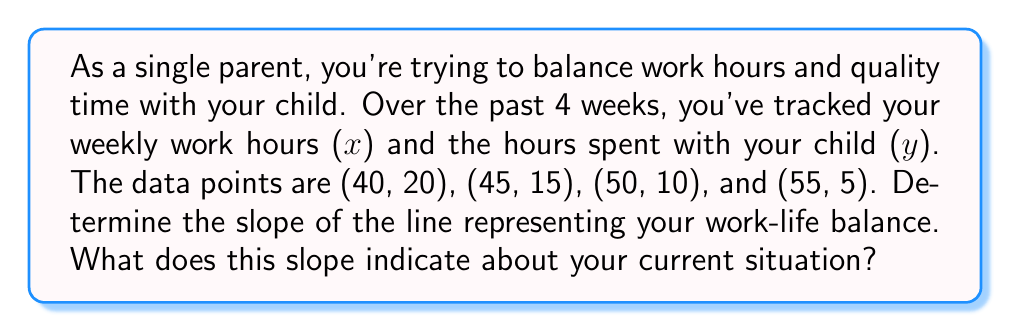Give your solution to this math problem. Let's approach this step-by-step:

1) The slope formula is:
   $m = \frac{y_2 - y_1}{x_2 - x_1}$

2) We can use any two points to calculate the slope. Let's use (40, 20) and (55, 5):
   $x_1 = 40$, $y_1 = 20$
   $x_2 = 55$, $y_2 = 5$

3) Plugging these into the slope formula:
   $m = \frac{5 - 20}{55 - 40} = \frac{-15}{15} = -1$

4) To verify, we can check with other points:
   $(45, 15)$ to $(50, 10)$: $m = \frac{10 - 15}{50 - 45} = \frac{-5}{5} = -1$

5) The slope is -1, which means for every 1 hour increase in work, there's a 1 hour decrease in time with your child.

6) This negative slope indicates an inverse relationship between work hours and time with your child, suggesting a challenging work-life balance.
Answer: $-1$ 